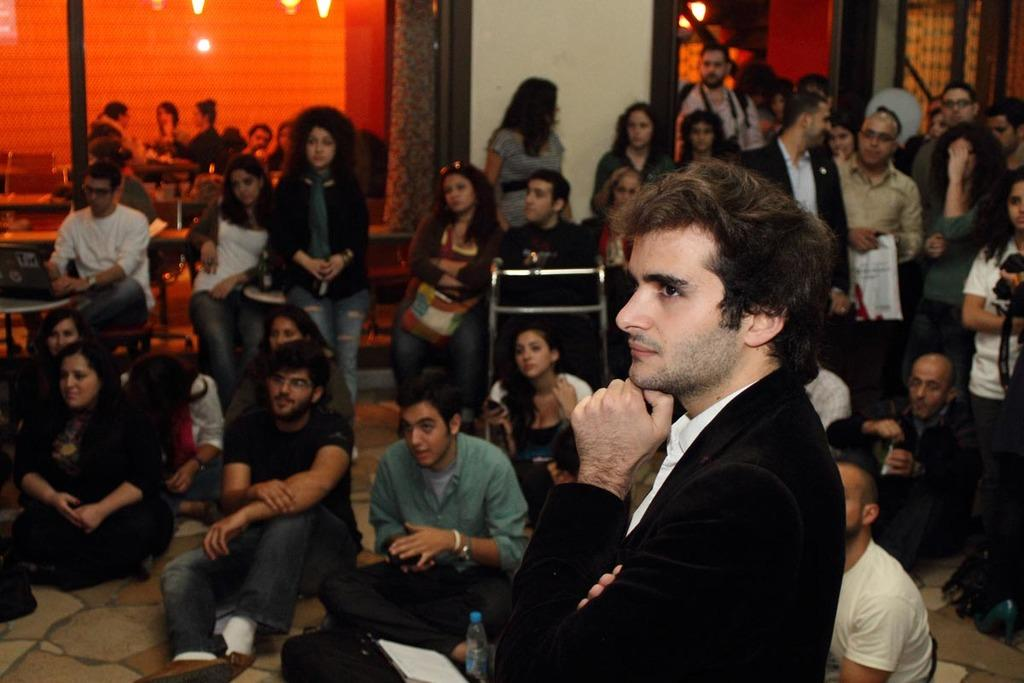What are the people in the image doing? Some people are standing, while others are seated on chairs or on the floor. Can you describe the seating arrangements in the image? Some people are seated on chairs, while others are seated on the floor. What can be seen in the image that provides illumination? There are lights visible in the image. What objects are being held by humans in the image? A human is holding a water bottle, and another human is holding a book. What type of representative is present in the image? There is no representative present in the image; it features people in various positions and holding objects. Can you describe the fight that is taking place in the image? There is no fight present in the image; the people are either standing, seated on chairs, or seated on the floor, and no conflict is depicted. 